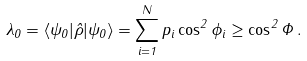Convert formula to latex. <formula><loc_0><loc_0><loc_500><loc_500>\lambda _ { 0 } = \langle \psi _ { 0 } | \hat { \rho } | \psi _ { 0 } \rangle = \sum _ { i = 1 } ^ { N } p _ { i } \cos ^ { 2 } \phi _ { i } \geq \cos ^ { 2 } \Phi \, .</formula> 